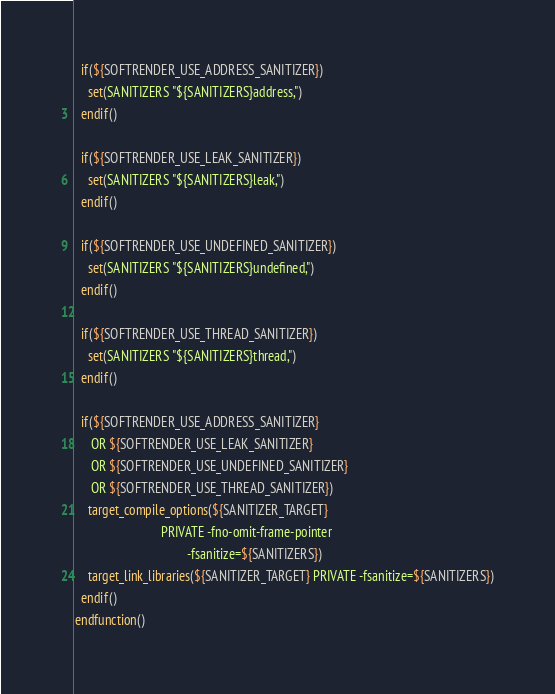Convert code to text. <code><loc_0><loc_0><loc_500><loc_500><_CMake_>
  if(${SOFTRENDER_USE_ADDRESS_SANITIZER})
    set(SANITIZERS "${SANITIZERS}address,")
  endif()

  if(${SOFTRENDER_USE_LEAK_SANITIZER})
    set(SANITIZERS "${SANITIZERS}leak,")
  endif()

  if(${SOFTRENDER_USE_UNDEFINED_SANITIZER})
    set(SANITIZERS "${SANITIZERS}undefined,")
  endif()

  if(${SOFTRENDER_USE_THREAD_SANITIZER})
    set(SANITIZERS "${SANITIZERS}thread,")
  endif()

  if(${SOFTRENDER_USE_ADDRESS_SANITIZER}
     OR ${SOFTRENDER_USE_LEAK_SANITIZER}
     OR ${SOFTRENDER_USE_UNDEFINED_SANITIZER}
     OR ${SOFTRENDER_USE_THREAD_SANITIZER})
    target_compile_options(${SANITIZER_TARGET}
                           PRIVATE -fno-omit-frame-pointer
                                   -fsanitize=${SANITIZERS})
    target_link_libraries(${SANITIZER_TARGET} PRIVATE -fsanitize=${SANITIZERS})
  endif()
endfunction()
</code> 